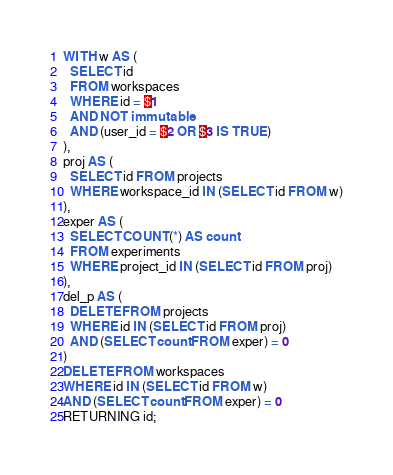<code> <loc_0><loc_0><loc_500><loc_500><_SQL_>WITH w AS (
  SELECT id
  FROM workspaces
  WHERE id = $1
  AND NOT immutable
  AND (user_id = $2 OR $3 IS TRUE)
),
proj AS (
  SELECT id FROM projects
  WHERE workspace_id IN (SELECT id FROM w)
),
exper AS (
  SELECT COUNT(*) AS count
  FROM experiments
  WHERE project_id IN (SELECT id FROM proj)
),
del_p AS (
  DELETE FROM projects
  WHERE id IN (SELECT id FROM proj)
  AND (SELECT count FROM exper) = 0
)
DELETE FROM workspaces
WHERE id IN (SELECT id FROM w)
AND (SELECT count FROM exper) = 0
RETURNING id;
</code> 